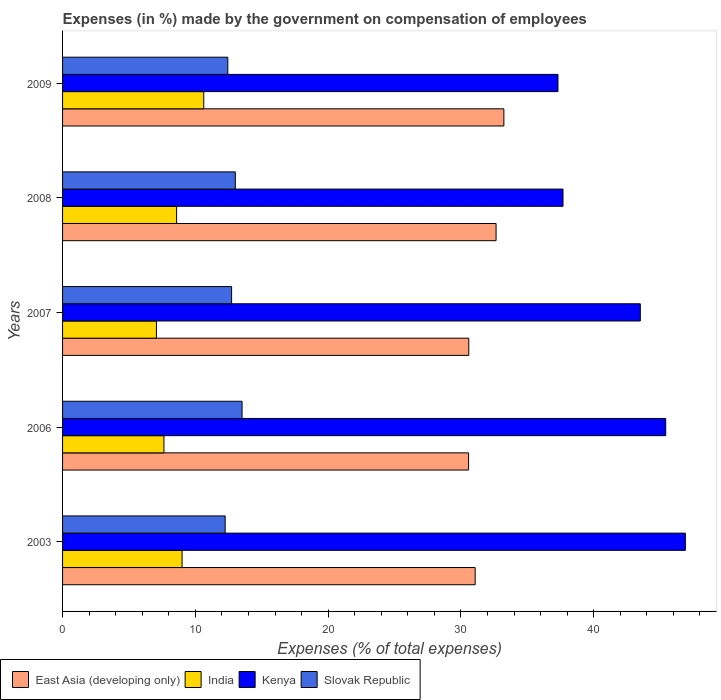Are the number of bars per tick equal to the number of legend labels?
Provide a succinct answer. Yes. Are the number of bars on each tick of the Y-axis equal?
Provide a short and direct response. Yes. How many bars are there on the 1st tick from the bottom?
Ensure brevity in your answer.  4. What is the percentage of expenses made by the government on compensation of employees in Slovak Republic in 2008?
Offer a very short reply. 13.01. Across all years, what is the maximum percentage of expenses made by the government on compensation of employees in Kenya?
Your answer should be very brief. 46.9. Across all years, what is the minimum percentage of expenses made by the government on compensation of employees in India?
Offer a very short reply. 7.07. In which year was the percentage of expenses made by the government on compensation of employees in Kenya minimum?
Your answer should be compact. 2009. What is the total percentage of expenses made by the government on compensation of employees in Kenya in the graph?
Provide a succinct answer. 210.84. What is the difference between the percentage of expenses made by the government on compensation of employees in East Asia (developing only) in 2003 and that in 2008?
Offer a terse response. -1.57. What is the difference between the percentage of expenses made by the government on compensation of employees in India in 2006 and the percentage of expenses made by the government on compensation of employees in Slovak Republic in 2008?
Provide a short and direct response. -5.37. What is the average percentage of expenses made by the government on compensation of employees in East Asia (developing only) per year?
Offer a terse response. 31.63. In the year 2009, what is the difference between the percentage of expenses made by the government on compensation of employees in Kenya and percentage of expenses made by the government on compensation of employees in Slovak Republic?
Keep it short and to the point. 24.86. In how many years, is the percentage of expenses made by the government on compensation of employees in Slovak Republic greater than 18 %?
Offer a terse response. 0. What is the ratio of the percentage of expenses made by the government on compensation of employees in East Asia (developing only) in 2003 to that in 2006?
Offer a very short reply. 1.02. Is the percentage of expenses made by the government on compensation of employees in India in 2008 less than that in 2009?
Your response must be concise. Yes. What is the difference between the highest and the second highest percentage of expenses made by the government on compensation of employees in East Asia (developing only)?
Your answer should be very brief. 0.59. What is the difference between the highest and the lowest percentage of expenses made by the government on compensation of employees in East Asia (developing only)?
Provide a short and direct response. 2.66. In how many years, is the percentage of expenses made by the government on compensation of employees in Kenya greater than the average percentage of expenses made by the government on compensation of employees in Kenya taken over all years?
Provide a succinct answer. 3. Is the sum of the percentage of expenses made by the government on compensation of employees in Kenya in 2006 and 2008 greater than the maximum percentage of expenses made by the government on compensation of employees in Slovak Republic across all years?
Ensure brevity in your answer.  Yes. What does the 3rd bar from the top in 2006 represents?
Give a very brief answer. India. What does the 1st bar from the bottom in 2007 represents?
Provide a short and direct response. East Asia (developing only). How many bars are there?
Keep it short and to the point. 20. What is the difference between two consecutive major ticks on the X-axis?
Your answer should be very brief. 10. Are the values on the major ticks of X-axis written in scientific E-notation?
Keep it short and to the point. No. Does the graph contain grids?
Keep it short and to the point. No. Where does the legend appear in the graph?
Offer a terse response. Bottom left. How are the legend labels stacked?
Offer a very short reply. Horizontal. What is the title of the graph?
Offer a very short reply. Expenses (in %) made by the government on compensation of employees. What is the label or title of the X-axis?
Provide a short and direct response. Expenses (% of total expenses). What is the label or title of the Y-axis?
Your response must be concise. Years. What is the Expenses (% of total expenses) in East Asia (developing only) in 2003?
Keep it short and to the point. 31.07. What is the Expenses (% of total expenses) of India in 2003?
Make the answer very short. 9. What is the Expenses (% of total expenses) in Kenya in 2003?
Keep it short and to the point. 46.9. What is the Expenses (% of total expenses) in Slovak Republic in 2003?
Your answer should be very brief. 12.25. What is the Expenses (% of total expenses) in East Asia (developing only) in 2006?
Ensure brevity in your answer.  30.58. What is the Expenses (% of total expenses) of India in 2006?
Offer a terse response. 7.64. What is the Expenses (% of total expenses) of Kenya in 2006?
Ensure brevity in your answer.  45.42. What is the Expenses (% of total expenses) of Slovak Republic in 2006?
Ensure brevity in your answer.  13.52. What is the Expenses (% of total expenses) of East Asia (developing only) in 2007?
Offer a very short reply. 30.59. What is the Expenses (% of total expenses) in India in 2007?
Give a very brief answer. 7.07. What is the Expenses (% of total expenses) of Kenya in 2007?
Offer a very short reply. 43.51. What is the Expenses (% of total expenses) in Slovak Republic in 2007?
Make the answer very short. 12.73. What is the Expenses (% of total expenses) of East Asia (developing only) in 2008?
Keep it short and to the point. 32.65. What is the Expenses (% of total expenses) of India in 2008?
Provide a short and direct response. 8.59. What is the Expenses (% of total expenses) in Kenya in 2008?
Your response must be concise. 37.69. What is the Expenses (% of total expenses) in Slovak Republic in 2008?
Provide a short and direct response. 13.01. What is the Expenses (% of total expenses) in East Asia (developing only) in 2009?
Provide a short and direct response. 33.24. What is the Expenses (% of total expenses) in India in 2009?
Offer a very short reply. 10.63. What is the Expenses (% of total expenses) of Kenya in 2009?
Give a very brief answer. 37.31. What is the Expenses (% of total expenses) of Slovak Republic in 2009?
Your response must be concise. 12.45. Across all years, what is the maximum Expenses (% of total expenses) of East Asia (developing only)?
Make the answer very short. 33.24. Across all years, what is the maximum Expenses (% of total expenses) in India?
Your answer should be very brief. 10.63. Across all years, what is the maximum Expenses (% of total expenses) of Kenya?
Provide a short and direct response. 46.9. Across all years, what is the maximum Expenses (% of total expenses) of Slovak Republic?
Offer a very short reply. 13.52. Across all years, what is the minimum Expenses (% of total expenses) of East Asia (developing only)?
Offer a very short reply. 30.58. Across all years, what is the minimum Expenses (% of total expenses) of India?
Ensure brevity in your answer.  7.07. Across all years, what is the minimum Expenses (% of total expenses) in Kenya?
Give a very brief answer. 37.31. Across all years, what is the minimum Expenses (% of total expenses) in Slovak Republic?
Provide a succinct answer. 12.25. What is the total Expenses (% of total expenses) of East Asia (developing only) in the graph?
Your response must be concise. 158.13. What is the total Expenses (% of total expenses) in India in the graph?
Offer a terse response. 42.93. What is the total Expenses (% of total expenses) in Kenya in the graph?
Offer a terse response. 210.84. What is the total Expenses (% of total expenses) in Slovak Republic in the graph?
Provide a succinct answer. 63.95. What is the difference between the Expenses (% of total expenses) of East Asia (developing only) in 2003 and that in 2006?
Give a very brief answer. 0.5. What is the difference between the Expenses (% of total expenses) of India in 2003 and that in 2006?
Keep it short and to the point. 1.37. What is the difference between the Expenses (% of total expenses) in Kenya in 2003 and that in 2006?
Keep it short and to the point. 1.48. What is the difference between the Expenses (% of total expenses) of Slovak Republic in 2003 and that in 2006?
Give a very brief answer. -1.27. What is the difference between the Expenses (% of total expenses) in East Asia (developing only) in 2003 and that in 2007?
Ensure brevity in your answer.  0.48. What is the difference between the Expenses (% of total expenses) of India in 2003 and that in 2007?
Give a very brief answer. 1.93. What is the difference between the Expenses (% of total expenses) of Kenya in 2003 and that in 2007?
Keep it short and to the point. 3.39. What is the difference between the Expenses (% of total expenses) of Slovak Republic in 2003 and that in 2007?
Give a very brief answer. -0.48. What is the difference between the Expenses (% of total expenses) in East Asia (developing only) in 2003 and that in 2008?
Your answer should be very brief. -1.57. What is the difference between the Expenses (% of total expenses) of India in 2003 and that in 2008?
Make the answer very short. 0.41. What is the difference between the Expenses (% of total expenses) of Kenya in 2003 and that in 2008?
Your answer should be very brief. 9.21. What is the difference between the Expenses (% of total expenses) of Slovak Republic in 2003 and that in 2008?
Provide a succinct answer. -0.76. What is the difference between the Expenses (% of total expenses) in East Asia (developing only) in 2003 and that in 2009?
Your answer should be very brief. -2.16. What is the difference between the Expenses (% of total expenses) of India in 2003 and that in 2009?
Keep it short and to the point. -1.63. What is the difference between the Expenses (% of total expenses) of Kenya in 2003 and that in 2009?
Ensure brevity in your answer.  9.59. What is the difference between the Expenses (% of total expenses) in Slovak Republic in 2003 and that in 2009?
Your answer should be very brief. -0.2. What is the difference between the Expenses (% of total expenses) in East Asia (developing only) in 2006 and that in 2007?
Ensure brevity in your answer.  -0.01. What is the difference between the Expenses (% of total expenses) of India in 2006 and that in 2007?
Give a very brief answer. 0.57. What is the difference between the Expenses (% of total expenses) of Kenya in 2006 and that in 2007?
Offer a terse response. 1.91. What is the difference between the Expenses (% of total expenses) in Slovak Republic in 2006 and that in 2007?
Provide a short and direct response. 0.79. What is the difference between the Expenses (% of total expenses) of East Asia (developing only) in 2006 and that in 2008?
Your answer should be compact. -2.07. What is the difference between the Expenses (% of total expenses) in India in 2006 and that in 2008?
Keep it short and to the point. -0.95. What is the difference between the Expenses (% of total expenses) in Kenya in 2006 and that in 2008?
Offer a terse response. 7.73. What is the difference between the Expenses (% of total expenses) in Slovak Republic in 2006 and that in 2008?
Provide a succinct answer. 0.51. What is the difference between the Expenses (% of total expenses) in East Asia (developing only) in 2006 and that in 2009?
Your answer should be very brief. -2.66. What is the difference between the Expenses (% of total expenses) of India in 2006 and that in 2009?
Your response must be concise. -3. What is the difference between the Expenses (% of total expenses) in Kenya in 2006 and that in 2009?
Your response must be concise. 8.11. What is the difference between the Expenses (% of total expenses) in Slovak Republic in 2006 and that in 2009?
Your answer should be very brief. 1.07. What is the difference between the Expenses (% of total expenses) of East Asia (developing only) in 2007 and that in 2008?
Your answer should be compact. -2.06. What is the difference between the Expenses (% of total expenses) of India in 2007 and that in 2008?
Make the answer very short. -1.52. What is the difference between the Expenses (% of total expenses) of Kenya in 2007 and that in 2008?
Offer a terse response. 5.82. What is the difference between the Expenses (% of total expenses) of Slovak Republic in 2007 and that in 2008?
Your answer should be very brief. -0.28. What is the difference between the Expenses (% of total expenses) of East Asia (developing only) in 2007 and that in 2009?
Keep it short and to the point. -2.64. What is the difference between the Expenses (% of total expenses) in India in 2007 and that in 2009?
Give a very brief answer. -3.56. What is the difference between the Expenses (% of total expenses) of Kenya in 2007 and that in 2009?
Provide a succinct answer. 6.2. What is the difference between the Expenses (% of total expenses) in Slovak Republic in 2007 and that in 2009?
Make the answer very short. 0.29. What is the difference between the Expenses (% of total expenses) of East Asia (developing only) in 2008 and that in 2009?
Make the answer very short. -0.59. What is the difference between the Expenses (% of total expenses) in India in 2008 and that in 2009?
Make the answer very short. -2.04. What is the difference between the Expenses (% of total expenses) of Kenya in 2008 and that in 2009?
Ensure brevity in your answer.  0.38. What is the difference between the Expenses (% of total expenses) in Slovak Republic in 2008 and that in 2009?
Offer a terse response. 0.56. What is the difference between the Expenses (% of total expenses) in East Asia (developing only) in 2003 and the Expenses (% of total expenses) in India in 2006?
Keep it short and to the point. 23.44. What is the difference between the Expenses (% of total expenses) of East Asia (developing only) in 2003 and the Expenses (% of total expenses) of Kenya in 2006?
Make the answer very short. -14.35. What is the difference between the Expenses (% of total expenses) in East Asia (developing only) in 2003 and the Expenses (% of total expenses) in Slovak Republic in 2006?
Your answer should be compact. 17.56. What is the difference between the Expenses (% of total expenses) of India in 2003 and the Expenses (% of total expenses) of Kenya in 2006?
Make the answer very short. -36.42. What is the difference between the Expenses (% of total expenses) of India in 2003 and the Expenses (% of total expenses) of Slovak Republic in 2006?
Your answer should be compact. -4.52. What is the difference between the Expenses (% of total expenses) in Kenya in 2003 and the Expenses (% of total expenses) in Slovak Republic in 2006?
Provide a short and direct response. 33.38. What is the difference between the Expenses (% of total expenses) in East Asia (developing only) in 2003 and the Expenses (% of total expenses) in India in 2007?
Offer a terse response. 24. What is the difference between the Expenses (% of total expenses) in East Asia (developing only) in 2003 and the Expenses (% of total expenses) in Kenya in 2007?
Offer a very short reply. -12.44. What is the difference between the Expenses (% of total expenses) in East Asia (developing only) in 2003 and the Expenses (% of total expenses) in Slovak Republic in 2007?
Keep it short and to the point. 18.34. What is the difference between the Expenses (% of total expenses) of India in 2003 and the Expenses (% of total expenses) of Kenya in 2007?
Provide a short and direct response. -34.51. What is the difference between the Expenses (% of total expenses) in India in 2003 and the Expenses (% of total expenses) in Slovak Republic in 2007?
Provide a short and direct response. -3.73. What is the difference between the Expenses (% of total expenses) of Kenya in 2003 and the Expenses (% of total expenses) of Slovak Republic in 2007?
Ensure brevity in your answer.  34.17. What is the difference between the Expenses (% of total expenses) of East Asia (developing only) in 2003 and the Expenses (% of total expenses) of India in 2008?
Make the answer very short. 22.49. What is the difference between the Expenses (% of total expenses) of East Asia (developing only) in 2003 and the Expenses (% of total expenses) of Kenya in 2008?
Keep it short and to the point. -6.61. What is the difference between the Expenses (% of total expenses) in East Asia (developing only) in 2003 and the Expenses (% of total expenses) in Slovak Republic in 2008?
Offer a terse response. 18.06. What is the difference between the Expenses (% of total expenses) in India in 2003 and the Expenses (% of total expenses) in Kenya in 2008?
Offer a terse response. -28.69. What is the difference between the Expenses (% of total expenses) in India in 2003 and the Expenses (% of total expenses) in Slovak Republic in 2008?
Your response must be concise. -4.01. What is the difference between the Expenses (% of total expenses) of Kenya in 2003 and the Expenses (% of total expenses) of Slovak Republic in 2008?
Your answer should be compact. 33.89. What is the difference between the Expenses (% of total expenses) in East Asia (developing only) in 2003 and the Expenses (% of total expenses) in India in 2009?
Provide a succinct answer. 20.44. What is the difference between the Expenses (% of total expenses) of East Asia (developing only) in 2003 and the Expenses (% of total expenses) of Kenya in 2009?
Offer a very short reply. -6.24. What is the difference between the Expenses (% of total expenses) in East Asia (developing only) in 2003 and the Expenses (% of total expenses) in Slovak Republic in 2009?
Keep it short and to the point. 18.63. What is the difference between the Expenses (% of total expenses) in India in 2003 and the Expenses (% of total expenses) in Kenya in 2009?
Provide a short and direct response. -28.31. What is the difference between the Expenses (% of total expenses) of India in 2003 and the Expenses (% of total expenses) of Slovak Republic in 2009?
Offer a very short reply. -3.44. What is the difference between the Expenses (% of total expenses) in Kenya in 2003 and the Expenses (% of total expenses) in Slovak Republic in 2009?
Your answer should be compact. 34.46. What is the difference between the Expenses (% of total expenses) of East Asia (developing only) in 2006 and the Expenses (% of total expenses) of India in 2007?
Your answer should be very brief. 23.51. What is the difference between the Expenses (% of total expenses) in East Asia (developing only) in 2006 and the Expenses (% of total expenses) in Kenya in 2007?
Provide a short and direct response. -12.93. What is the difference between the Expenses (% of total expenses) in East Asia (developing only) in 2006 and the Expenses (% of total expenses) in Slovak Republic in 2007?
Your answer should be compact. 17.85. What is the difference between the Expenses (% of total expenses) in India in 2006 and the Expenses (% of total expenses) in Kenya in 2007?
Your response must be concise. -35.88. What is the difference between the Expenses (% of total expenses) of India in 2006 and the Expenses (% of total expenses) of Slovak Republic in 2007?
Provide a succinct answer. -5.1. What is the difference between the Expenses (% of total expenses) of Kenya in 2006 and the Expenses (% of total expenses) of Slovak Republic in 2007?
Your answer should be compact. 32.69. What is the difference between the Expenses (% of total expenses) of East Asia (developing only) in 2006 and the Expenses (% of total expenses) of India in 2008?
Keep it short and to the point. 21.99. What is the difference between the Expenses (% of total expenses) of East Asia (developing only) in 2006 and the Expenses (% of total expenses) of Kenya in 2008?
Your answer should be compact. -7.11. What is the difference between the Expenses (% of total expenses) of East Asia (developing only) in 2006 and the Expenses (% of total expenses) of Slovak Republic in 2008?
Offer a very short reply. 17.57. What is the difference between the Expenses (% of total expenses) in India in 2006 and the Expenses (% of total expenses) in Kenya in 2008?
Give a very brief answer. -30.05. What is the difference between the Expenses (% of total expenses) of India in 2006 and the Expenses (% of total expenses) of Slovak Republic in 2008?
Make the answer very short. -5.37. What is the difference between the Expenses (% of total expenses) of Kenya in 2006 and the Expenses (% of total expenses) of Slovak Republic in 2008?
Your answer should be compact. 32.41. What is the difference between the Expenses (% of total expenses) of East Asia (developing only) in 2006 and the Expenses (% of total expenses) of India in 2009?
Keep it short and to the point. 19.94. What is the difference between the Expenses (% of total expenses) of East Asia (developing only) in 2006 and the Expenses (% of total expenses) of Kenya in 2009?
Make the answer very short. -6.73. What is the difference between the Expenses (% of total expenses) in East Asia (developing only) in 2006 and the Expenses (% of total expenses) in Slovak Republic in 2009?
Your answer should be very brief. 18.13. What is the difference between the Expenses (% of total expenses) of India in 2006 and the Expenses (% of total expenses) of Kenya in 2009?
Ensure brevity in your answer.  -29.67. What is the difference between the Expenses (% of total expenses) in India in 2006 and the Expenses (% of total expenses) in Slovak Republic in 2009?
Your answer should be compact. -4.81. What is the difference between the Expenses (% of total expenses) of Kenya in 2006 and the Expenses (% of total expenses) of Slovak Republic in 2009?
Keep it short and to the point. 32.98. What is the difference between the Expenses (% of total expenses) of East Asia (developing only) in 2007 and the Expenses (% of total expenses) of India in 2008?
Provide a short and direct response. 22. What is the difference between the Expenses (% of total expenses) of East Asia (developing only) in 2007 and the Expenses (% of total expenses) of Kenya in 2008?
Your answer should be compact. -7.1. What is the difference between the Expenses (% of total expenses) in East Asia (developing only) in 2007 and the Expenses (% of total expenses) in Slovak Republic in 2008?
Provide a succinct answer. 17.58. What is the difference between the Expenses (% of total expenses) of India in 2007 and the Expenses (% of total expenses) of Kenya in 2008?
Keep it short and to the point. -30.62. What is the difference between the Expenses (% of total expenses) of India in 2007 and the Expenses (% of total expenses) of Slovak Republic in 2008?
Offer a terse response. -5.94. What is the difference between the Expenses (% of total expenses) in Kenya in 2007 and the Expenses (% of total expenses) in Slovak Republic in 2008?
Offer a very short reply. 30.5. What is the difference between the Expenses (% of total expenses) of East Asia (developing only) in 2007 and the Expenses (% of total expenses) of India in 2009?
Ensure brevity in your answer.  19.96. What is the difference between the Expenses (% of total expenses) in East Asia (developing only) in 2007 and the Expenses (% of total expenses) in Kenya in 2009?
Your response must be concise. -6.72. What is the difference between the Expenses (% of total expenses) in East Asia (developing only) in 2007 and the Expenses (% of total expenses) in Slovak Republic in 2009?
Provide a succinct answer. 18.15. What is the difference between the Expenses (% of total expenses) of India in 2007 and the Expenses (% of total expenses) of Kenya in 2009?
Your response must be concise. -30.24. What is the difference between the Expenses (% of total expenses) of India in 2007 and the Expenses (% of total expenses) of Slovak Republic in 2009?
Your answer should be very brief. -5.38. What is the difference between the Expenses (% of total expenses) in Kenya in 2007 and the Expenses (% of total expenses) in Slovak Republic in 2009?
Your response must be concise. 31.07. What is the difference between the Expenses (% of total expenses) of East Asia (developing only) in 2008 and the Expenses (% of total expenses) of India in 2009?
Provide a succinct answer. 22.02. What is the difference between the Expenses (% of total expenses) in East Asia (developing only) in 2008 and the Expenses (% of total expenses) in Kenya in 2009?
Offer a very short reply. -4.66. What is the difference between the Expenses (% of total expenses) of East Asia (developing only) in 2008 and the Expenses (% of total expenses) of Slovak Republic in 2009?
Offer a very short reply. 20.2. What is the difference between the Expenses (% of total expenses) of India in 2008 and the Expenses (% of total expenses) of Kenya in 2009?
Your answer should be compact. -28.72. What is the difference between the Expenses (% of total expenses) of India in 2008 and the Expenses (% of total expenses) of Slovak Republic in 2009?
Keep it short and to the point. -3.86. What is the difference between the Expenses (% of total expenses) of Kenya in 2008 and the Expenses (% of total expenses) of Slovak Republic in 2009?
Provide a succinct answer. 25.24. What is the average Expenses (% of total expenses) of East Asia (developing only) per year?
Keep it short and to the point. 31.63. What is the average Expenses (% of total expenses) of India per year?
Your answer should be very brief. 8.59. What is the average Expenses (% of total expenses) in Kenya per year?
Your response must be concise. 42.17. What is the average Expenses (% of total expenses) in Slovak Republic per year?
Offer a terse response. 12.79. In the year 2003, what is the difference between the Expenses (% of total expenses) in East Asia (developing only) and Expenses (% of total expenses) in India?
Your response must be concise. 22.07. In the year 2003, what is the difference between the Expenses (% of total expenses) in East Asia (developing only) and Expenses (% of total expenses) in Kenya?
Keep it short and to the point. -15.83. In the year 2003, what is the difference between the Expenses (% of total expenses) of East Asia (developing only) and Expenses (% of total expenses) of Slovak Republic?
Offer a terse response. 18.83. In the year 2003, what is the difference between the Expenses (% of total expenses) in India and Expenses (% of total expenses) in Kenya?
Provide a succinct answer. -37.9. In the year 2003, what is the difference between the Expenses (% of total expenses) of India and Expenses (% of total expenses) of Slovak Republic?
Provide a succinct answer. -3.24. In the year 2003, what is the difference between the Expenses (% of total expenses) of Kenya and Expenses (% of total expenses) of Slovak Republic?
Make the answer very short. 34.66. In the year 2006, what is the difference between the Expenses (% of total expenses) in East Asia (developing only) and Expenses (% of total expenses) in India?
Provide a succinct answer. 22.94. In the year 2006, what is the difference between the Expenses (% of total expenses) of East Asia (developing only) and Expenses (% of total expenses) of Kenya?
Make the answer very short. -14.85. In the year 2006, what is the difference between the Expenses (% of total expenses) in East Asia (developing only) and Expenses (% of total expenses) in Slovak Republic?
Your answer should be compact. 17.06. In the year 2006, what is the difference between the Expenses (% of total expenses) of India and Expenses (% of total expenses) of Kenya?
Provide a short and direct response. -37.79. In the year 2006, what is the difference between the Expenses (% of total expenses) in India and Expenses (% of total expenses) in Slovak Republic?
Provide a succinct answer. -5.88. In the year 2006, what is the difference between the Expenses (% of total expenses) of Kenya and Expenses (% of total expenses) of Slovak Republic?
Your response must be concise. 31.9. In the year 2007, what is the difference between the Expenses (% of total expenses) in East Asia (developing only) and Expenses (% of total expenses) in India?
Ensure brevity in your answer.  23.52. In the year 2007, what is the difference between the Expenses (% of total expenses) of East Asia (developing only) and Expenses (% of total expenses) of Kenya?
Keep it short and to the point. -12.92. In the year 2007, what is the difference between the Expenses (% of total expenses) in East Asia (developing only) and Expenses (% of total expenses) in Slovak Republic?
Your answer should be compact. 17.86. In the year 2007, what is the difference between the Expenses (% of total expenses) in India and Expenses (% of total expenses) in Kenya?
Give a very brief answer. -36.44. In the year 2007, what is the difference between the Expenses (% of total expenses) in India and Expenses (% of total expenses) in Slovak Republic?
Offer a very short reply. -5.66. In the year 2007, what is the difference between the Expenses (% of total expenses) in Kenya and Expenses (% of total expenses) in Slovak Republic?
Your answer should be very brief. 30.78. In the year 2008, what is the difference between the Expenses (% of total expenses) of East Asia (developing only) and Expenses (% of total expenses) of India?
Give a very brief answer. 24.06. In the year 2008, what is the difference between the Expenses (% of total expenses) of East Asia (developing only) and Expenses (% of total expenses) of Kenya?
Provide a short and direct response. -5.04. In the year 2008, what is the difference between the Expenses (% of total expenses) in East Asia (developing only) and Expenses (% of total expenses) in Slovak Republic?
Provide a succinct answer. 19.64. In the year 2008, what is the difference between the Expenses (% of total expenses) in India and Expenses (% of total expenses) in Kenya?
Provide a short and direct response. -29.1. In the year 2008, what is the difference between the Expenses (% of total expenses) in India and Expenses (% of total expenses) in Slovak Republic?
Provide a short and direct response. -4.42. In the year 2008, what is the difference between the Expenses (% of total expenses) in Kenya and Expenses (% of total expenses) in Slovak Republic?
Provide a succinct answer. 24.68. In the year 2009, what is the difference between the Expenses (% of total expenses) in East Asia (developing only) and Expenses (% of total expenses) in India?
Your answer should be compact. 22.6. In the year 2009, what is the difference between the Expenses (% of total expenses) of East Asia (developing only) and Expenses (% of total expenses) of Kenya?
Offer a very short reply. -4.07. In the year 2009, what is the difference between the Expenses (% of total expenses) of East Asia (developing only) and Expenses (% of total expenses) of Slovak Republic?
Make the answer very short. 20.79. In the year 2009, what is the difference between the Expenses (% of total expenses) in India and Expenses (% of total expenses) in Kenya?
Offer a very short reply. -26.68. In the year 2009, what is the difference between the Expenses (% of total expenses) in India and Expenses (% of total expenses) in Slovak Republic?
Ensure brevity in your answer.  -1.81. In the year 2009, what is the difference between the Expenses (% of total expenses) in Kenya and Expenses (% of total expenses) in Slovak Republic?
Provide a short and direct response. 24.86. What is the ratio of the Expenses (% of total expenses) in East Asia (developing only) in 2003 to that in 2006?
Offer a very short reply. 1.02. What is the ratio of the Expenses (% of total expenses) of India in 2003 to that in 2006?
Offer a very short reply. 1.18. What is the ratio of the Expenses (% of total expenses) in Kenya in 2003 to that in 2006?
Your response must be concise. 1.03. What is the ratio of the Expenses (% of total expenses) in Slovak Republic in 2003 to that in 2006?
Ensure brevity in your answer.  0.91. What is the ratio of the Expenses (% of total expenses) in East Asia (developing only) in 2003 to that in 2007?
Your response must be concise. 1.02. What is the ratio of the Expenses (% of total expenses) in India in 2003 to that in 2007?
Provide a succinct answer. 1.27. What is the ratio of the Expenses (% of total expenses) of Kenya in 2003 to that in 2007?
Your response must be concise. 1.08. What is the ratio of the Expenses (% of total expenses) in Slovak Republic in 2003 to that in 2007?
Make the answer very short. 0.96. What is the ratio of the Expenses (% of total expenses) of East Asia (developing only) in 2003 to that in 2008?
Provide a succinct answer. 0.95. What is the ratio of the Expenses (% of total expenses) in India in 2003 to that in 2008?
Ensure brevity in your answer.  1.05. What is the ratio of the Expenses (% of total expenses) of Kenya in 2003 to that in 2008?
Give a very brief answer. 1.24. What is the ratio of the Expenses (% of total expenses) in Slovak Republic in 2003 to that in 2008?
Give a very brief answer. 0.94. What is the ratio of the Expenses (% of total expenses) in East Asia (developing only) in 2003 to that in 2009?
Offer a very short reply. 0.94. What is the ratio of the Expenses (% of total expenses) of India in 2003 to that in 2009?
Your answer should be very brief. 0.85. What is the ratio of the Expenses (% of total expenses) in Kenya in 2003 to that in 2009?
Make the answer very short. 1.26. What is the ratio of the Expenses (% of total expenses) in Slovak Republic in 2003 to that in 2009?
Your response must be concise. 0.98. What is the ratio of the Expenses (% of total expenses) in India in 2006 to that in 2007?
Provide a short and direct response. 1.08. What is the ratio of the Expenses (% of total expenses) of Kenya in 2006 to that in 2007?
Your response must be concise. 1.04. What is the ratio of the Expenses (% of total expenses) of Slovak Republic in 2006 to that in 2007?
Offer a very short reply. 1.06. What is the ratio of the Expenses (% of total expenses) of East Asia (developing only) in 2006 to that in 2008?
Your response must be concise. 0.94. What is the ratio of the Expenses (% of total expenses) in India in 2006 to that in 2008?
Ensure brevity in your answer.  0.89. What is the ratio of the Expenses (% of total expenses) in Kenya in 2006 to that in 2008?
Your answer should be very brief. 1.21. What is the ratio of the Expenses (% of total expenses) in Slovak Republic in 2006 to that in 2008?
Your answer should be very brief. 1.04. What is the ratio of the Expenses (% of total expenses) in East Asia (developing only) in 2006 to that in 2009?
Your response must be concise. 0.92. What is the ratio of the Expenses (% of total expenses) in India in 2006 to that in 2009?
Provide a succinct answer. 0.72. What is the ratio of the Expenses (% of total expenses) of Kenya in 2006 to that in 2009?
Your answer should be compact. 1.22. What is the ratio of the Expenses (% of total expenses) of Slovak Republic in 2006 to that in 2009?
Make the answer very short. 1.09. What is the ratio of the Expenses (% of total expenses) in East Asia (developing only) in 2007 to that in 2008?
Keep it short and to the point. 0.94. What is the ratio of the Expenses (% of total expenses) in India in 2007 to that in 2008?
Make the answer very short. 0.82. What is the ratio of the Expenses (% of total expenses) of Kenya in 2007 to that in 2008?
Offer a terse response. 1.15. What is the ratio of the Expenses (% of total expenses) in Slovak Republic in 2007 to that in 2008?
Keep it short and to the point. 0.98. What is the ratio of the Expenses (% of total expenses) in East Asia (developing only) in 2007 to that in 2009?
Your answer should be compact. 0.92. What is the ratio of the Expenses (% of total expenses) of India in 2007 to that in 2009?
Ensure brevity in your answer.  0.66. What is the ratio of the Expenses (% of total expenses) in Kenya in 2007 to that in 2009?
Give a very brief answer. 1.17. What is the ratio of the Expenses (% of total expenses) in Slovak Republic in 2007 to that in 2009?
Your answer should be very brief. 1.02. What is the ratio of the Expenses (% of total expenses) in East Asia (developing only) in 2008 to that in 2009?
Keep it short and to the point. 0.98. What is the ratio of the Expenses (% of total expenses) in India in 2008 to that in 2009?
Offer a very short reply. 0.81. What is the ratio of the Expenses (% of total expenses) in Kenya in 2008 to that in 2009?
Provide a short and direct response. 1.01. What is the ratio of the Expenses (% of total expenses) of Slovak Republic in 2008 to that in 2009?
Your answer should be very brief. 1.05. What is the difference between the highest and the second highest Expenses (% of total expenses) in East Asia (developing only)?
Your answer should be compact. 0.59. What is the difference between the highest and the second highest Expenses (% of total expenses) in India?
Your answer should be very brief. 1.63. What is the difference between the highest and the second highest Expenses (% of total expenses) of Kenya?
Give a very brief answer. 1.48. What is the difference between the highest and the second highest Expenses (% of total expenses) of Slovak Republic?
Ensure brevity in your answer.  0.51. What is the difference between the highest and the lowest Expenses (% of total expenses) in East Asia (developing only)?
Keep it short and to the point. 2.66. What is the difference between the highest and the lowest Expenses (% of total expenses) in India?
Make the answer very short. 3.56. What is the difference between the highest and the lowest Expenses (% of total expenses) in Kenya?
Ensure brevity in your answer.  9.59. What is the difference between the highest and the lowest Expenses (% of total expenses) of Slovak Republic?
Provide a succinct answer. 1.27. 